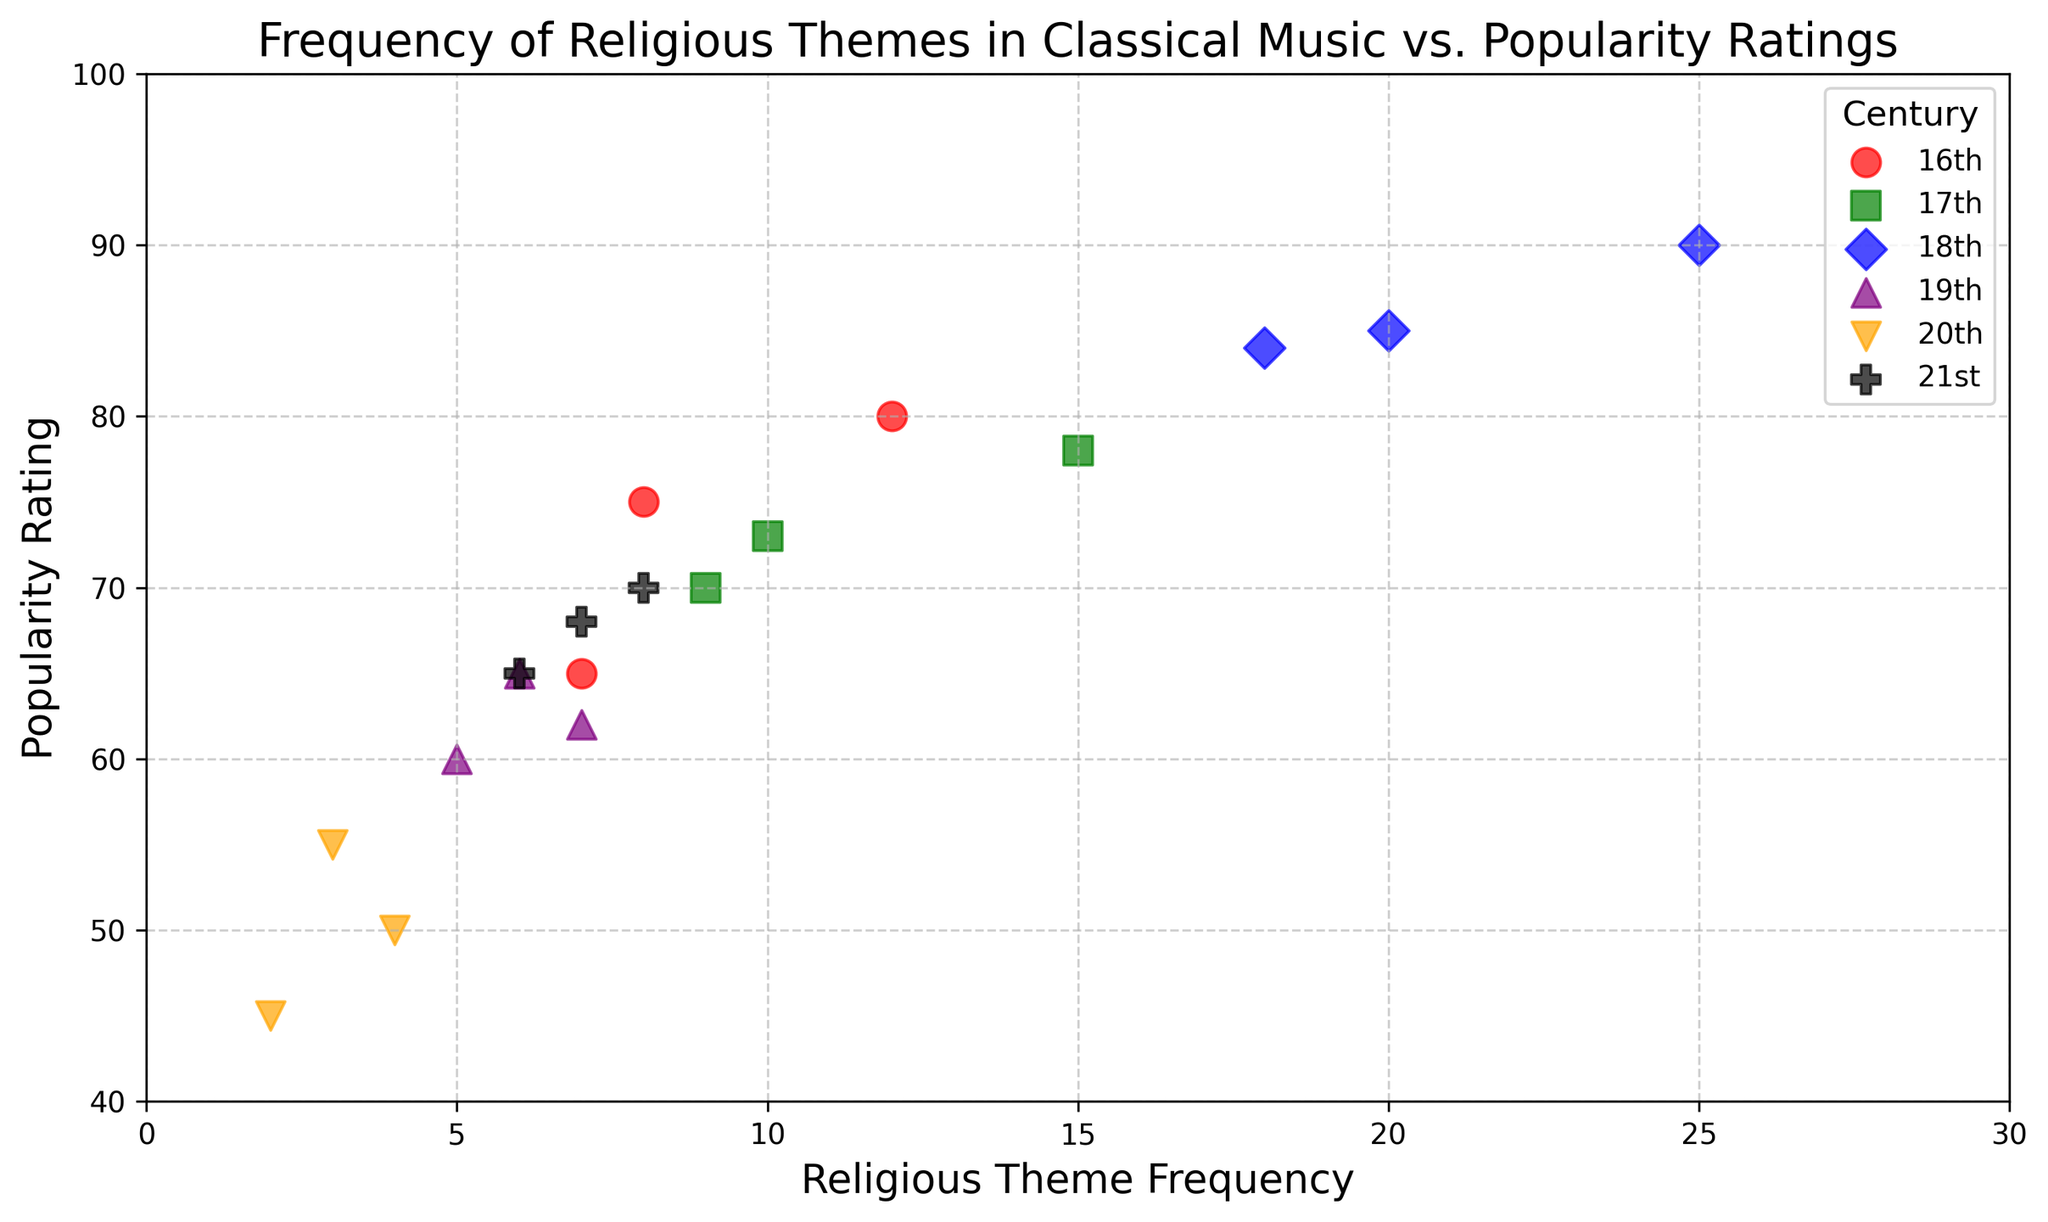What is the overall trend in the popularity ratings as the frequency of religious themes increases? Observe how the points generally align across the centuries. As the frequency of religious themes increases, there is a clear upward trend in the popularity ratings, particularly noticeable in the 18th century.
Answer: Increasing Which century has the highest frequency of religious themes? Look for the century with the highest data points on the x-axis. The 18th century data points reach up to 25, which is the highest among all.
Answer: 18th Which century has the lowest popularity rating for a given frequency of religious themes? Examine the y-axis to find the lowest popularity rating, which is found in the 20th century at 45.
Answer: 20th How do the 21st-century data points compare to those of the 16th century in terms of frequency of religious themes? Compare the x-axis positions of the 16th and 21st-century markers. The 21st-century frequencies are between 6 and 8, whereas the 16th-century frequencies range between 7 and 12.
Answer: Lower in 21st century What is the average popularity rating for the 19th century data points? Calculate the average of the popularity ratings for the 19th century. The values are 60, 62, and 65. The sum is 187, so the average is 187/3 = 62.33.
Answer: 62.33 How does the popularity rating in the 20th century compare to the 21st century for similar frequencies of religious themes? Notice where the 20th and 21st-century points overlap or are close on the x-axis. For frequencies around 3-4, the popularity ratings in the 20th century (45-55) are lower compared to the 21st century (65-70).
Answer: Higher in 21st century Are there more data points in the 18th century or the 19th century? Count the number of data points for each century. There are three data points for the 19th century and three for the 18th century.
Answer: Equal Which century shows the most variation in popularity ratings? Look for the widest range of values on the y-axis for each century. The variation can be calculated by subtracting the minimum from the maximum value. The 20th-century values range from 45 to 55, the 16th-century values from 65 to 80, etc. The widest range is found in the 16th century (15 units from 65 to 80).
Answer: 16th What is the difference in the highest popularity rating between the 18th and 17th centuries? Identify the highest popularity ratings for the 18th century (90) and the 17th century (78), then calculate the difference. 90 - 78 = 12.
Answer: 12 